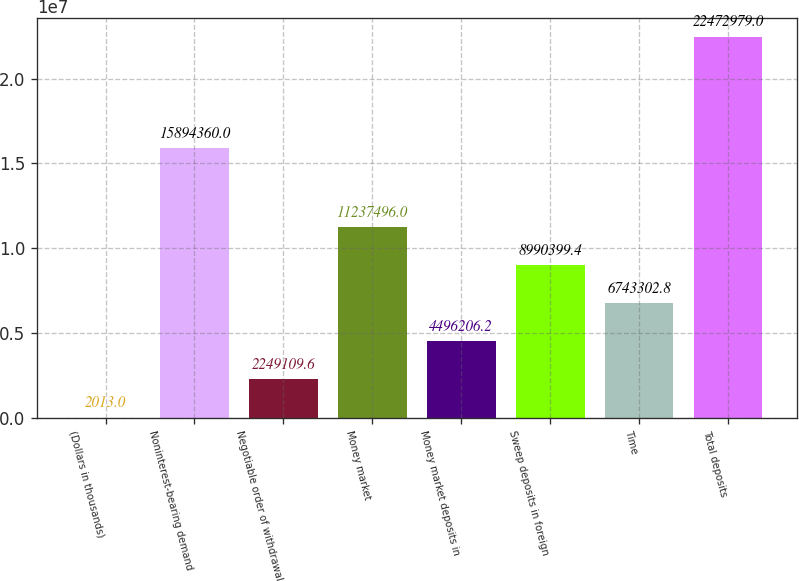Convert chart to OTSL. <chart><loc_0><loc_0><loc_500><loc_500><bar_chart><fcel>(Dollars in thousands)<fcel>Noninterest-bearing demand<fcel>Negotiable order of withdrawal<fcel>Money market<fcel>Money market deposits in<fcel>Sweep deposits in foreign<fcel>Time<fcel>Total deposits<nl><fcel>2013<fcel>1.58944e+07<fcel>2.24911e+06<fcel>1.12375e+07<fcel>4.49621e+06<fcel>8.9904e+06<fcel>6.7433e+06<fcel>2.2473e+07<nl></chart> 